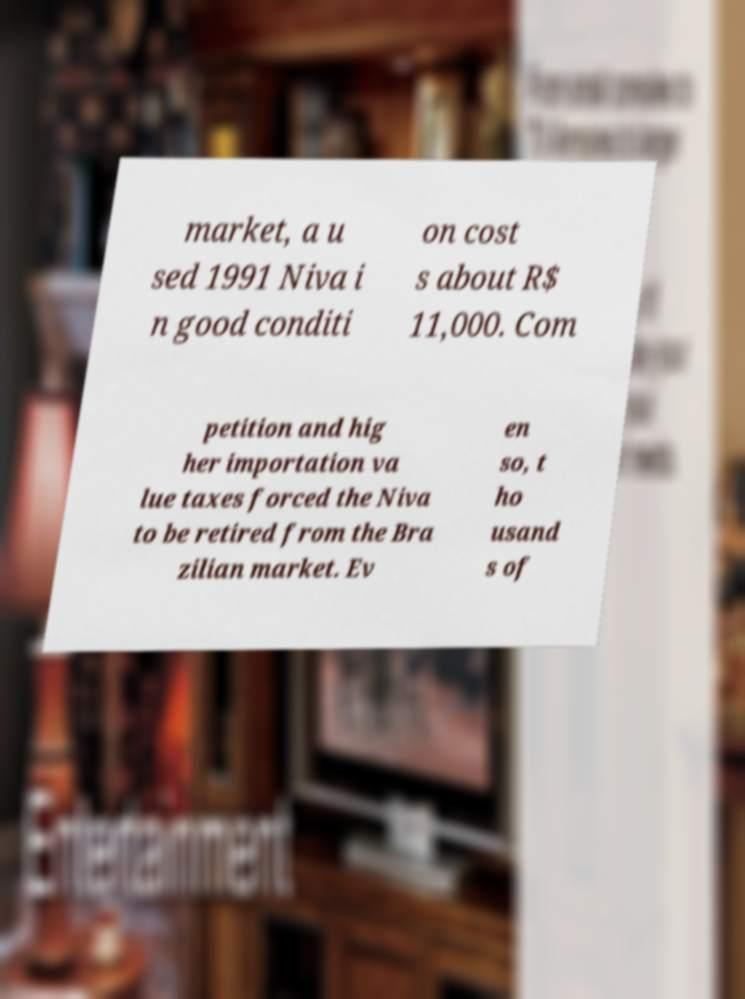Could you extract and type out the text from this image? market, a u sed 1991 Niva i n good conditi on cost s about R$ 11,000. Com petition and hig her importation va lue taxes forced the Niva to be retired from the Bra zilian market. Ev en so, t ho usand s of 